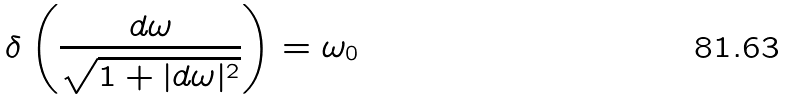<formula> <loc_0><loc_0><loc_500><loc_500>\delta \left ( \frac { d \omega } { \sqrt { 1 + | d \omega | ^ { 2 } } } \right ) = \omega _ { 0 }</formula> 